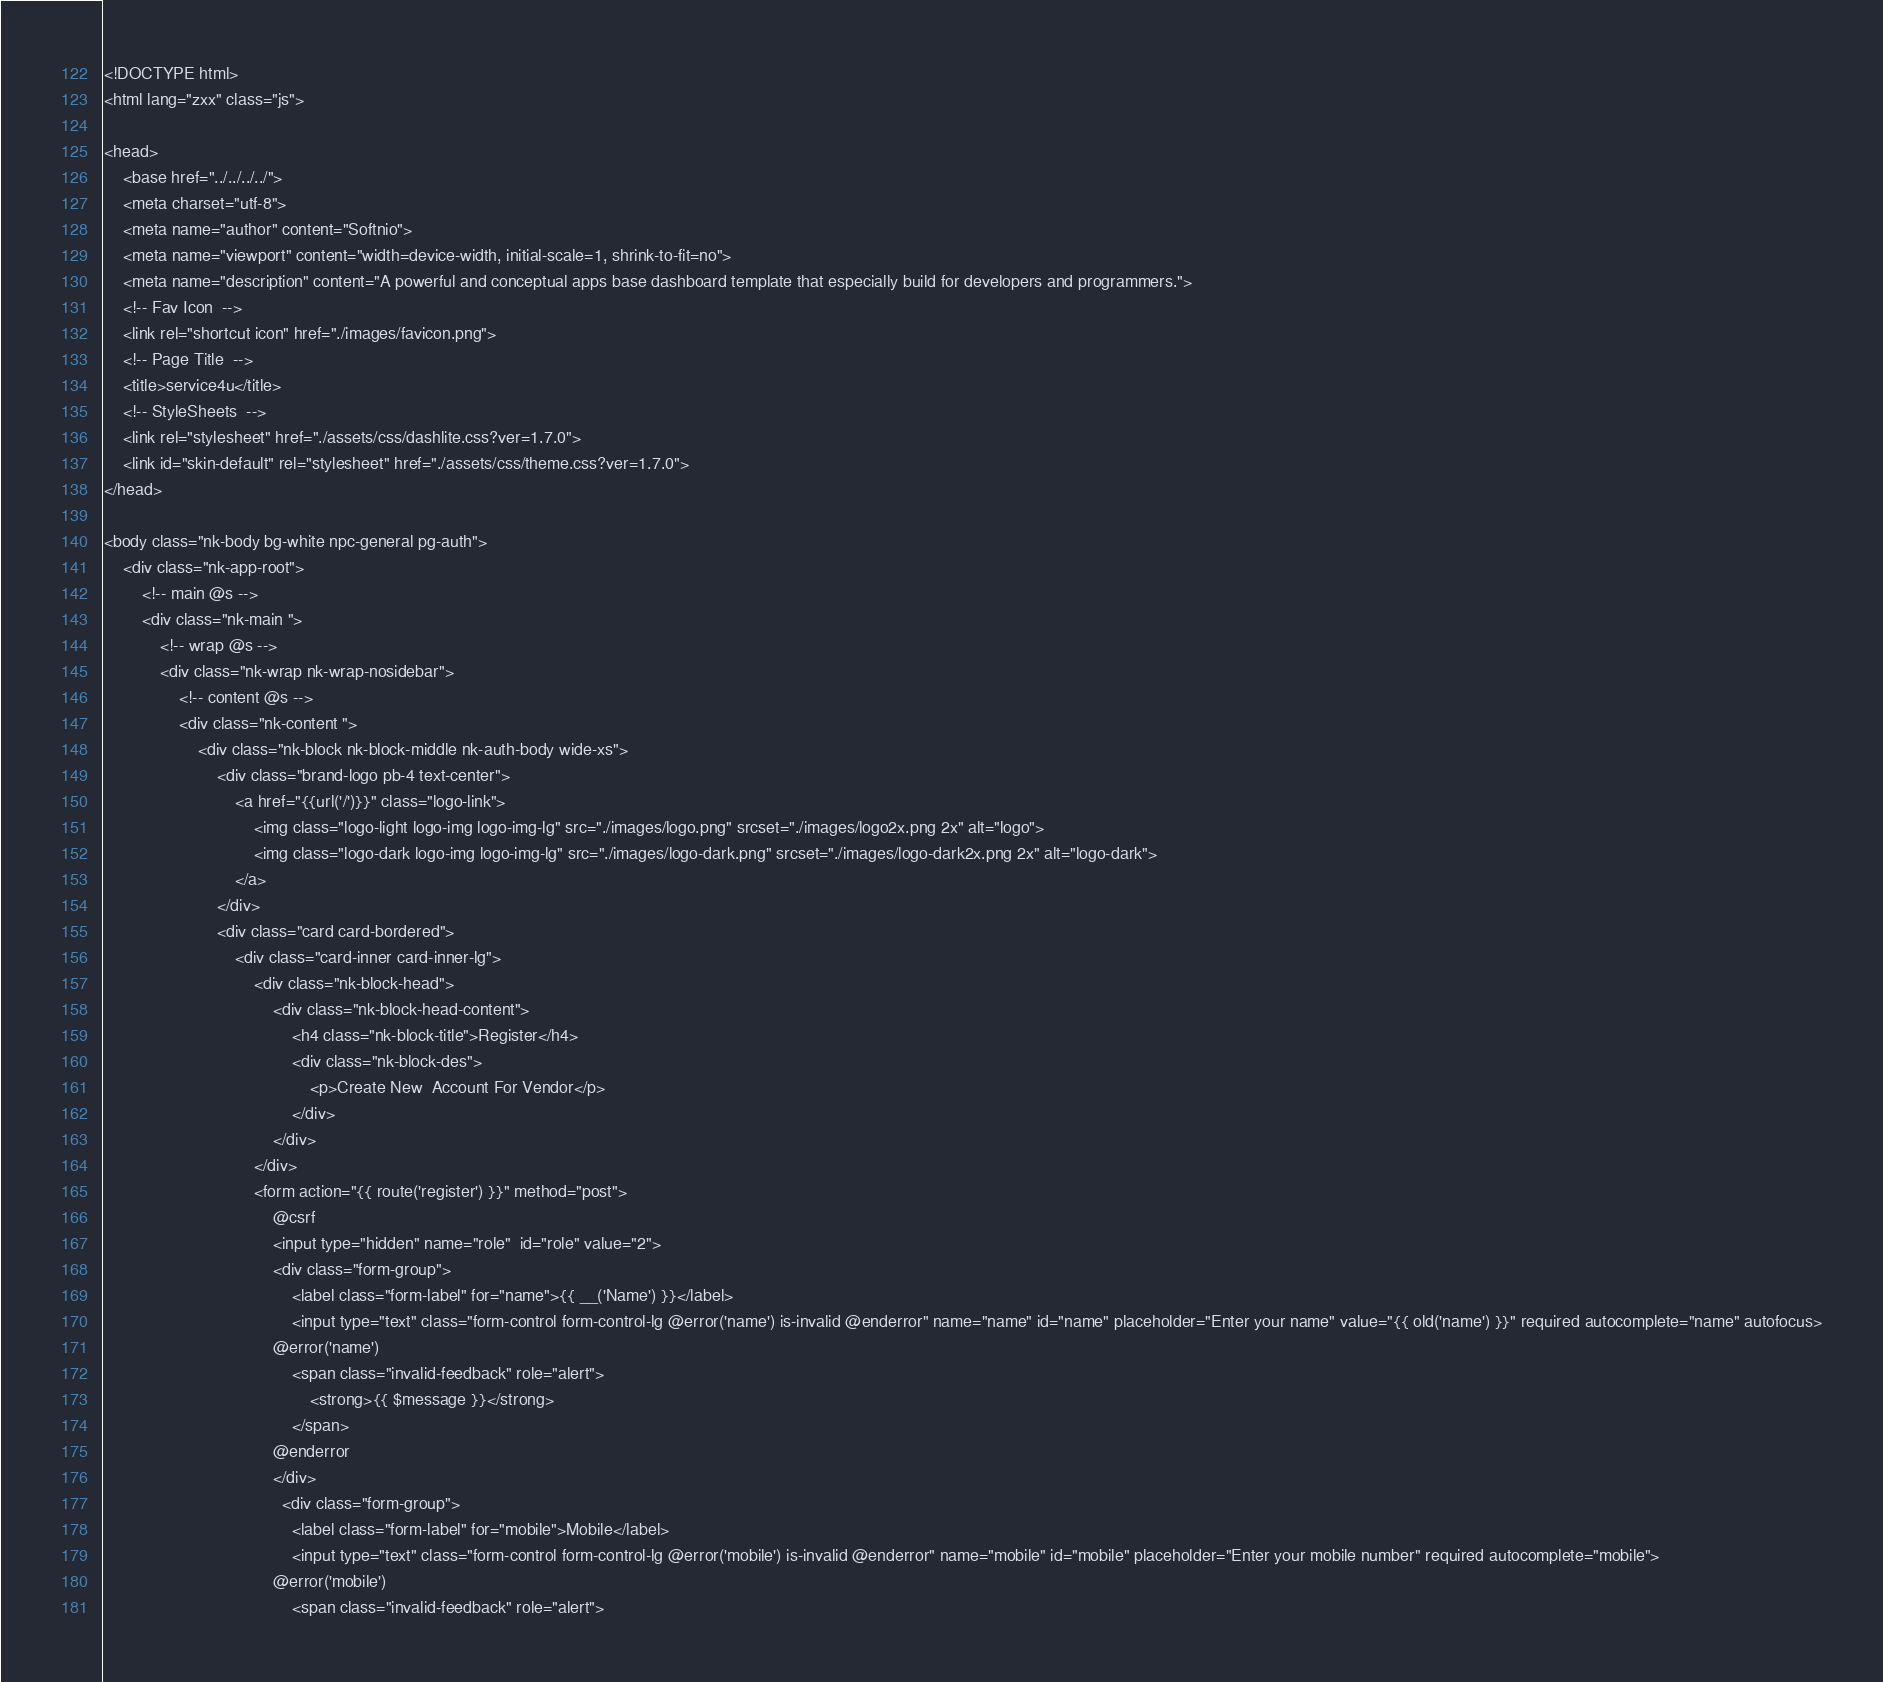<code> <loc_0><loc_0><loc_500><loc_500><_PHP_><!DOCTYPE html>
<html lang="zxx" class="js">

<head>
    <base href="../../../../">
    <meta charset="utf-8">
    <meta name="author" content="Softnio">
    <meta name="viewport" content="width=device-width, initial-scale=1, shrink-to-fit=no">
    <meta name="description" content="A powerful and conceptual apps base dashboard template that especially build for developers and programmers.">
    <!-- Fav Icon  -->
    <link rel="shortcut icon" href="./images/favicon.png">
    <!-- Page Title  -->
    <title>service4u</title>
    <!-- StyleSheets  -->
    <link rel="stylesheet" href="./assets/css/dashlite.css?ver=1.7.0">
    <link id="skin-default" rel="stylesheet" href="./assets/css/theme.css?ver=1.7.0">
</head>

<body class="nk-body bg-white npc-general pg-auth">
    <div class="nk-app-root">
        <!-- main @s -->
        <div class="nk-main ">
            <!-- wrap @s -->
            <div class="nk-wrap nk-wrap-nosidebar">
                <!-- content @s -->
                <div class="nk-content ">
                    <div class="nk-block nk-block-middle nk-auth-body wide-xs">
                        <div class="brand-logo pb-4 text-center">
                            <a href="{{url('/')}}" class="logo-link">
                                <img class="logo-light logo-img logo-img-lg" src="./images/logo.png" srcset="./images/logo2x.png 2x" alt="logo">
                                <img class="logo-dark logo-img logo-img-lg" src="./images/logo-dark.png" srcset="./images/logo-dark2x.png 2x" alt="logo-dark">
                            </a>
                        </div>
                        <div class="card card-bordered">
                            <div class="card-inner card-inner-lg">
                                <div class="nk-block-head">
                                    <div class="nk-block-head-content">
                                        <h4 class="nk-block-title">Register</h4>
                                        <div class="nk-block-des">
                                            <p>Create New  Account For Vendor</p>
                                        </div>
                                    </div>
                                </div>
                                <form action="{{ route('register') }}" method="post">
                                    @csrf
                                    <input type="hidden" name="role"  id="role" value="2">
                                    <div class="form-group">
                                        <label class="form-label" for="name">{{ __('Name') }}</label>
                                        <input type="text" class="form-control form-control-lg @error('name') is-invalid @enderror" name="name" id="name" placeholder="Enter your name" value="{{ old('name') }}" required autocomplete="name" autofocus>
                                    @error('name')
                                        <span class="invalid-feedback" role="alert">
                                            <strong>{{ $message }}</strong>
                                        </span>
                                    @enderror
                                    </div>
                                      <div class="form-group">
                                        <label class="form-label" for="mobile">Mobile</label>
                                        <input type="text" class="form-control form-control-lg @error('mobile') is-invalid @enderror" name="mobile" id="mobile" placeholder="Enter your mobile number" required autocomplete="mobile">
                                    @error('mobile')
                                        <span class="invalid-feedback" role="alert"></code> 